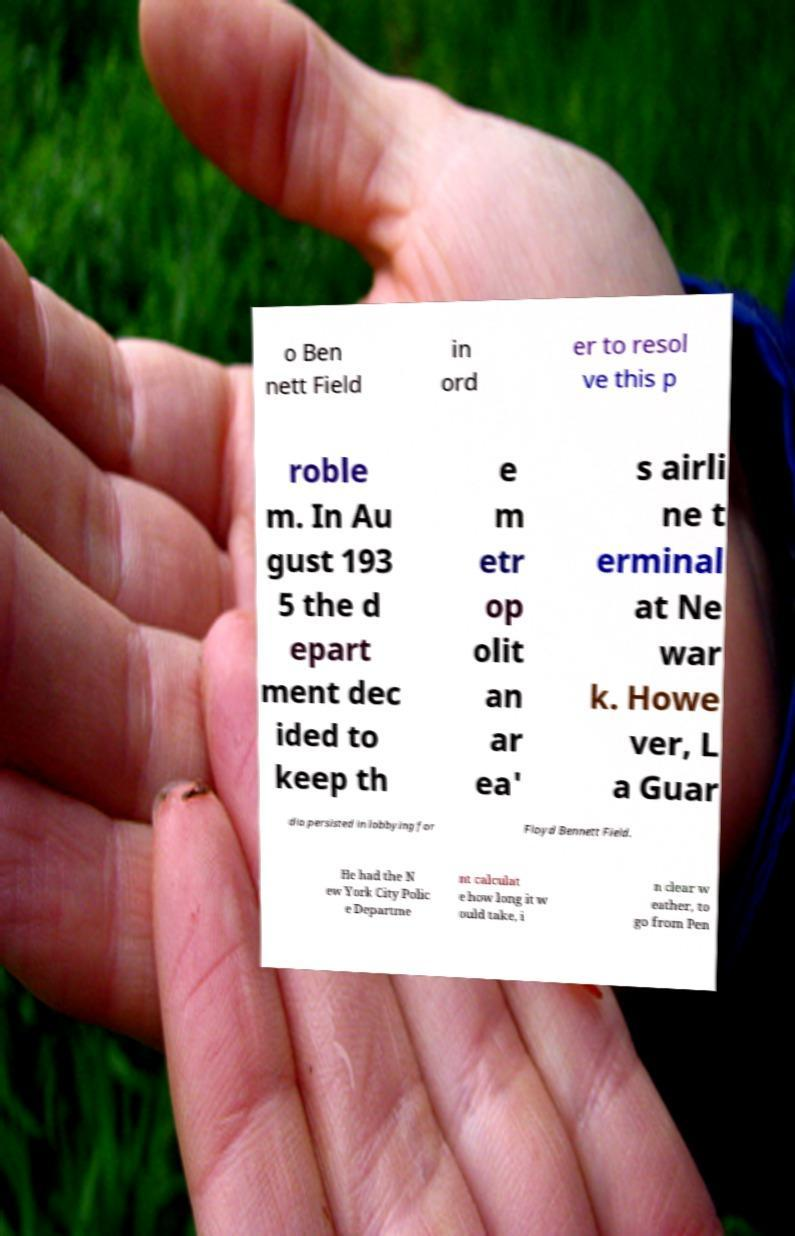Can you read and provide the text displayed in the image?This photo seems to have some interesting text. Can you extract and type it out for me? o Ben nett Field in ord er to resol ve this p roble m. In Au gust 193 5 the d epart ment dec ided to keep th e m etr op olit an ar ea' s airli ne t erminal at Ne war k. Howe ver, L a Guar dia persisted in lobbying for Floyd Bennett Field. He had the N ew York City Polic e Departme nt calculat e how long it w ould take, i n clear w eather, to go from Pen 